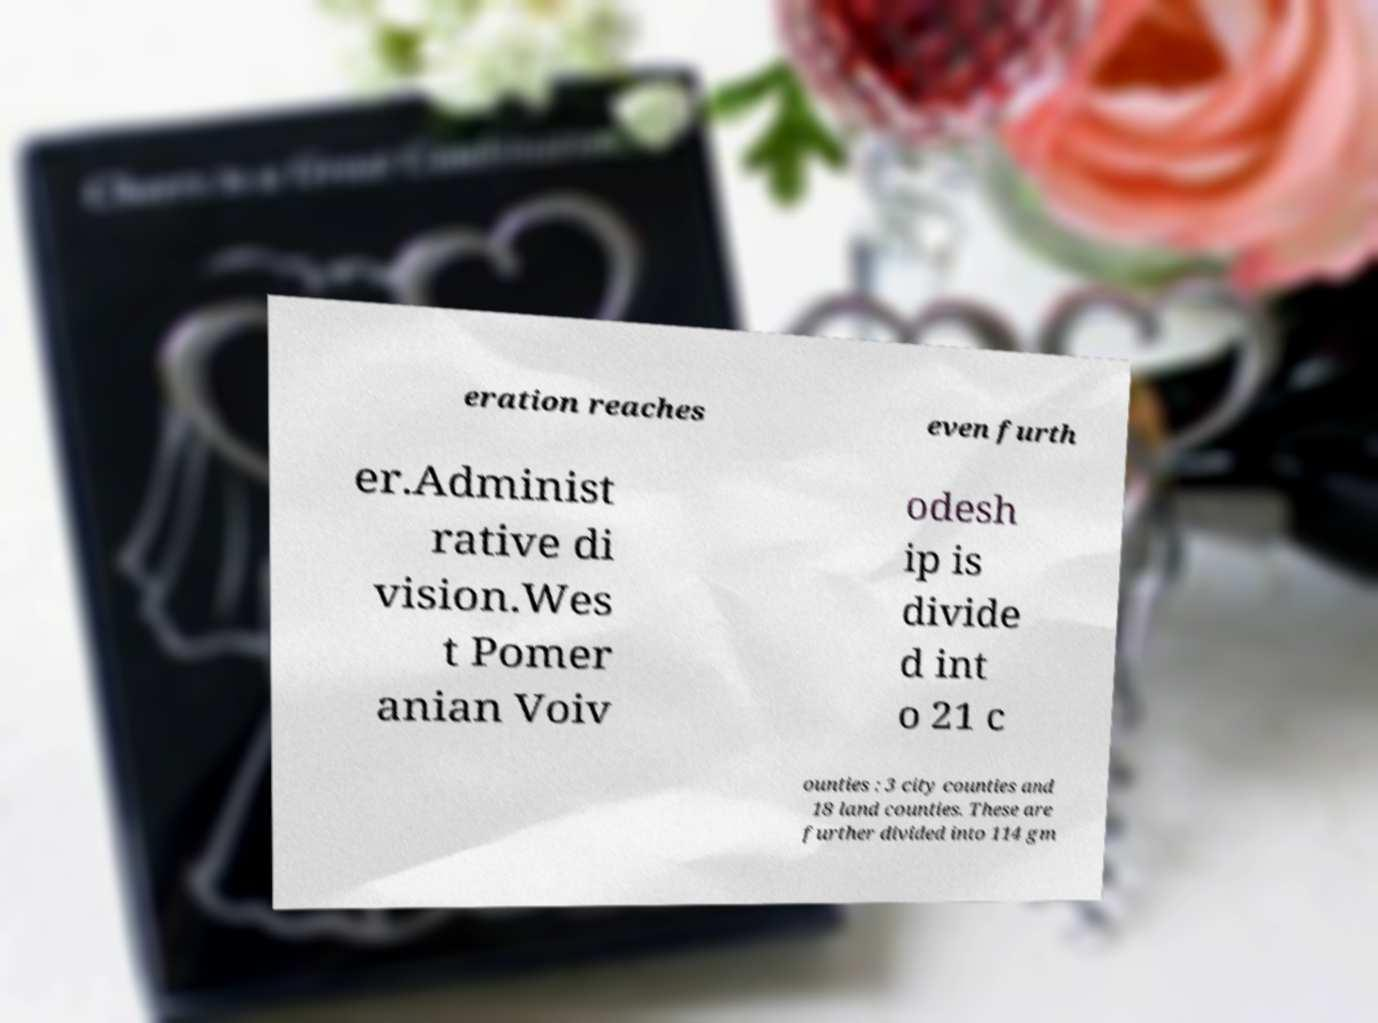There's text embedded in this image that I need extracted. Can you transcribe it verbatim? eration reaches even furth er.Administ rative di vision.Wes t Pomer anian Voiv odesh ip is divide d int o 21 c ounties : 3 city counties and 18 land counties. These are further divided into 114 gm 